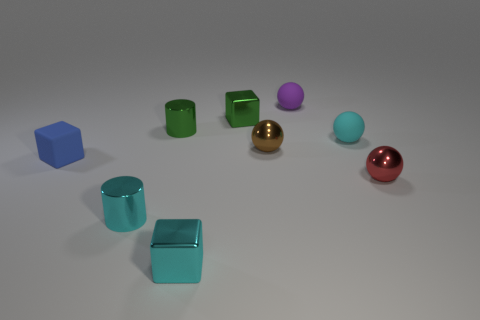How many small green things are behind the cylinder that is behind the tiny matte thing left of the tiny purple thing?
Ensure brevity in your answer.  1. There is a tiny metallic sphere that is to the right of the tiny brown object; is it the same color as the matte block?
Your response must be concise. No. What number of other objects are the same shape as the tiny purple rubber thing?
Give a very brief answer. 3. What number of other things are made of the same material as the tiny brown sphere?
Offer a terse response. 5. What material is the small green object on the right side of the metallic cylinder that is behind the tiny rubber cube in front of the tiny brown ball made of?
Provide a short and direct response. Metal. Is the blue block made of the same material as the tiny cyan cylinder?
Provide a succinct answer. No. What number of cylinders are either green objects or small blue rubber things?
Make the answer very short. 1. There is a tiny ball in front of the brown thing; what is its color?
Make the answer very short. Red. How many matte things are either red spheres or big red blocks?
Keep it short and to the point. 0. What material is the block that is left of the block in front of the red metallic thing?
Your response must be concise. Rubber. 